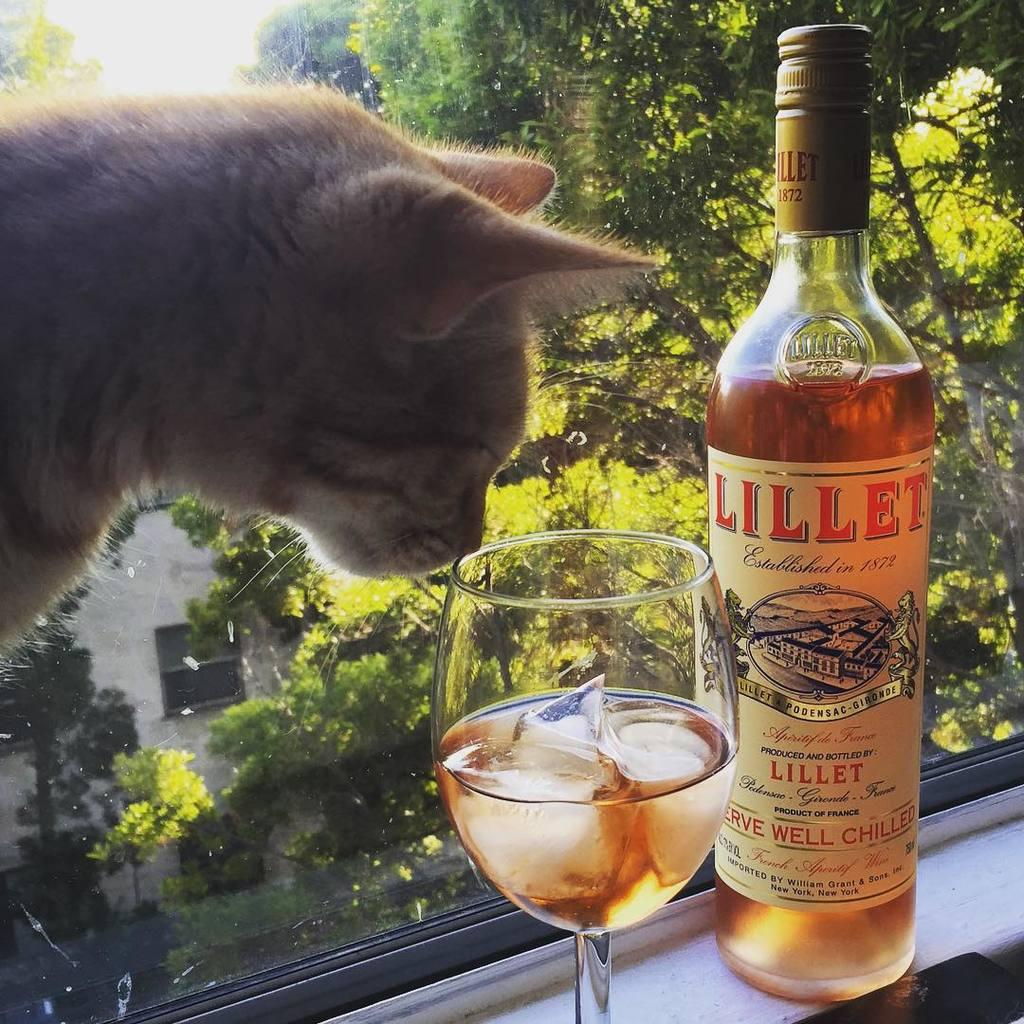Provide a one-sentence caption for the provided image. A cat is near a glass of wine that is near a bottle of Lillet wine. 